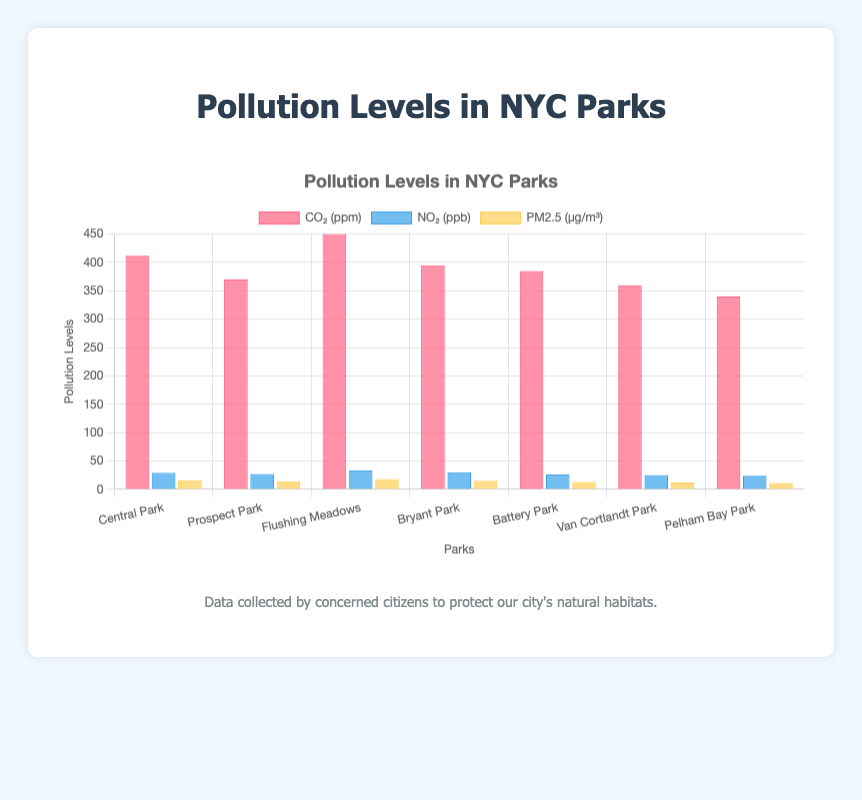What's the CO2 level in Flushing Meadows? The CO2 level in Flushing Meadows can be directly read from the "Flushing Meadows" bar under the "CO₂ (ppm)" label.
Answer: 450 ppm Which park has the lowest NO2 levels? To determine the park with the lowest NO2 levels, compare all the NO2 values. Pelham Bay Park has the lowest NO2 level of 24 ppb.
Answer: Pelham Bay Park What is the total PM2.5 level across all the parks? Sum the PM2.5 values of all the parks: 16 (Central Park) + 14 (Prospect Park) + 18 (Flushing Meadows) + 15 (Bryant Park) + 13 (Battery Park) + 12 (Van Cortlandt Park) + 11 (Pelham Bay Park) = 99 µg/m³.
Answer: 99 µg/m³ How does Central Park's NO2 level compare to Prospect Park's NO2 level? Central Park's NO2 level is 29 ppb, and Prospect Park's NO2 level is 27 ppb. Central Park's NO2 level is 2 ppb higher than that of Prospect Park.
Answer: Central Park NO2 is higher Which pollutant shows the largest difference between the highest and lowest values across the parks? Calculate the difference for each pollutant:
CO₂: 450 (highest) - 340 (lowest) = 110 ppm
NO₂: 33 (highest) - 24 (lowest) = 9 ppb
PM2.5: 18 (highest) - 11 (lowest) = 7 µg/m³
The largest difference is in CO2 levels.
Answer: CO2 Which park has the highest level of PM2.5, and what is that level? Find the highest PM2.5 value: Flushing Meadows has the highest PM2.5 level with a value of 18 µg/m³.
Answer: Flushing Meadows, 18 µg/m³ What is the average CO2 level for all the parks? Sum the CO2 levels and divide by the number of parks: (412 + 370 + 450 + 395 + 385 + 360 + 340) / 7 = 2712 / 7 = 387.43 ppm.
Answer: 387.43 ppm Compare the pollutant levels in Battery Park to Van Cortlandt Park. Battery Park: CO₂ = 385, NO₂ = 26, PM2.5 = 13; Van Cortlandt Park: CO₂ = 360, NO₂ = 25, PM2.5 = 12. Battery Park has higher levels of all pollutants compared to Van Cortlandt Park.
Answer: Battery Park has higher levels What is the difference in the PM2.5 levels between the park with the highest and the park with the lowest PM2.5 levels? The park with the highest PM2.5 level is Flushing Meadows (18 µg/m³), and the park with the lowest PM2.5 level is Pelham Bay Park (11 µg/m³). The difference is 18 - 11 = 7 µg/m³.
Answer: 7 µg/m³ What's the sum of NO2 levels in Central Park and Flushing Meadows? Sum the NO2 levels: 29 (Central Park) + 33 (Flushing Meadows) = 62 ppb.
Answer: 62 ppb 